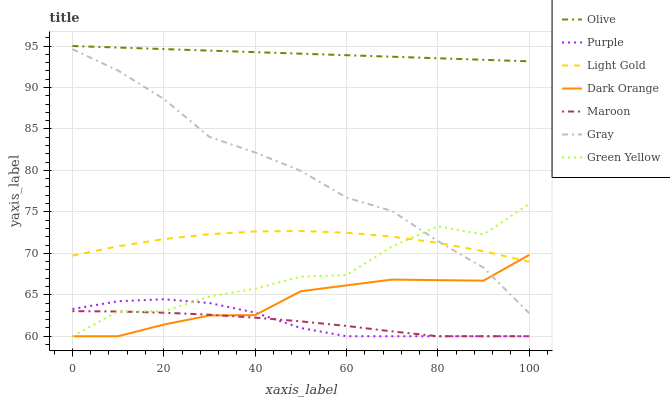Does Dark Orange have the minimum area under the curve?
Answer yes or no. No. Does Dark Orange have the maximum area under the curve?
Answer yes or no. No. Is Dark Orange the smoothest?
Answer yes or no. No. Is Dark Orange the roughest?
Answer yes or no. No. Does Olive have the lowest value?
Answer yes or no. No. Does Dark Orange have the highest value?
Answer yes or no. No. Is Maroon less than Olive?
Answer yes or no. Yes. Is Light Gold greater than Purple?
Answer yes or no. Yes. Does Maroon intersect Olive?
Answer yes or no. No. 